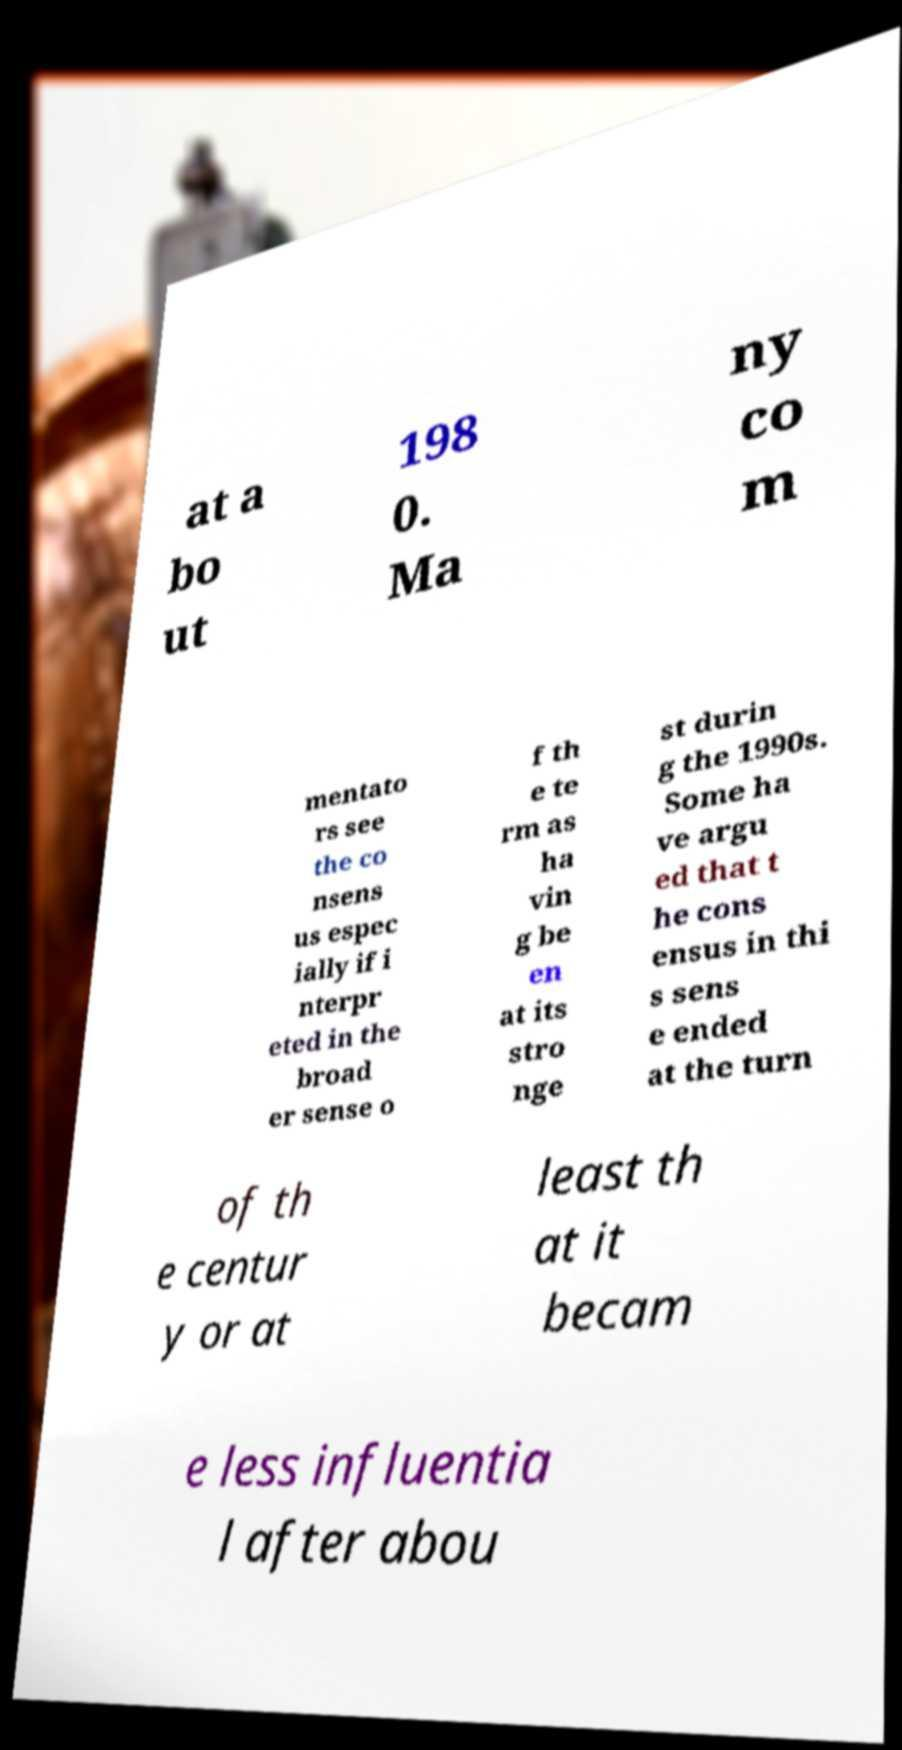Can you accurately transcribe the text from the provided image for me? at a bo ut 198 0. Ma ny co m mentato rs see the co nsens us espec ially if i nterpr eted in the broad er sense o f th e te rm as ha vin g be en at its stro nge st durin g the 1990s. Some ha ve argu ed that t he cons ensus in thi s sens e ended at the turn of th e centur y or at least th at it becam e less influentia l after abou 